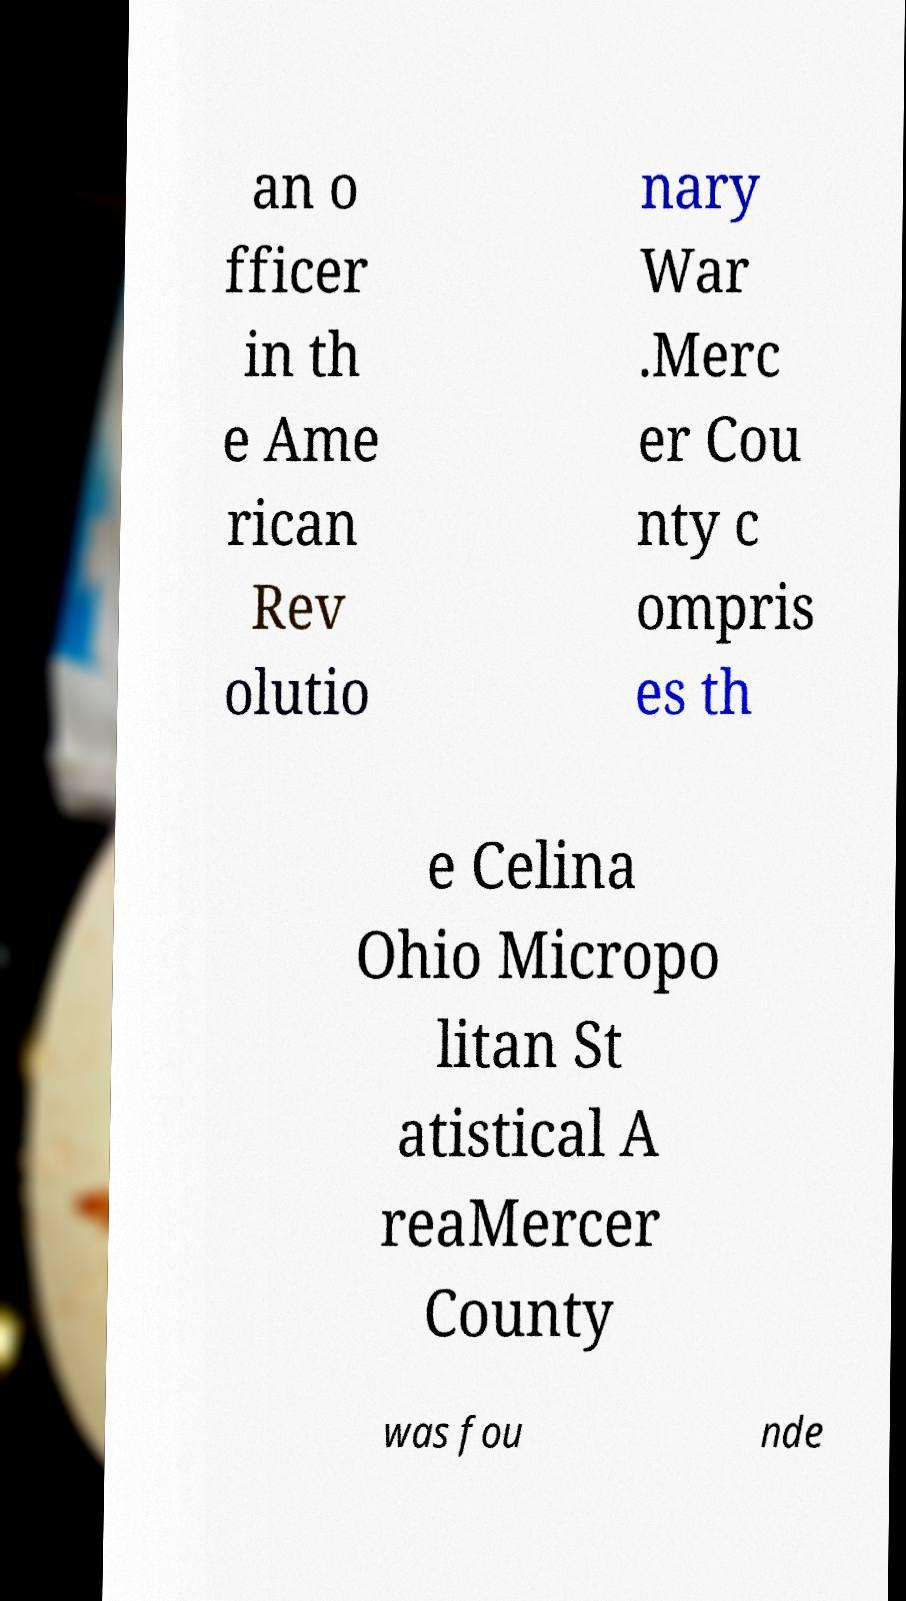There's text embedded in this image that I need extracted. Can you transcribe it verbatim? an o fficer in th e Ame rican Rev olutio nary War .Merc er Cou nty c ompris es th e Celina Ohio Micropo litan St atistical A reaMercer County was fou nde 